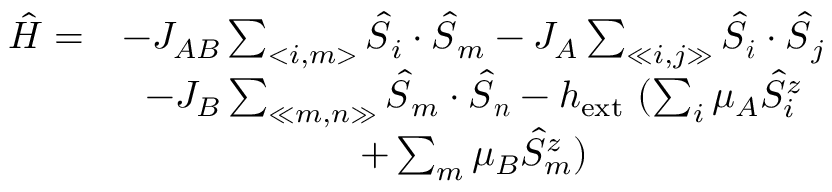<formula> <loc_0><loc_0><loc_500><loc_500>\begin{array} { r c } { \hat { H } = } & { - J _ { A B } \sum _ { < i , m > } \hat { S } _ { i } \cdot \hat { S } _ { m } - J _ { A } \sum _ { \ll i , j \gg } \hat { S } _ { i } \cdot \hat { S } _ { j } } \\ & { - J _ { B } \sum _ { \ll m , n \gg } \hat { S } _ { m } \cdot \hat { S } _ { n } - h _ { e x t } ( \sum _ { i } \mu _ { A } \hat { S } _ { i } ^ { z } } \\ & { + \sum _ { m } \mu _ { B } \hat { S } _ { m } ^ { z } ) } \end{array}</formula> 